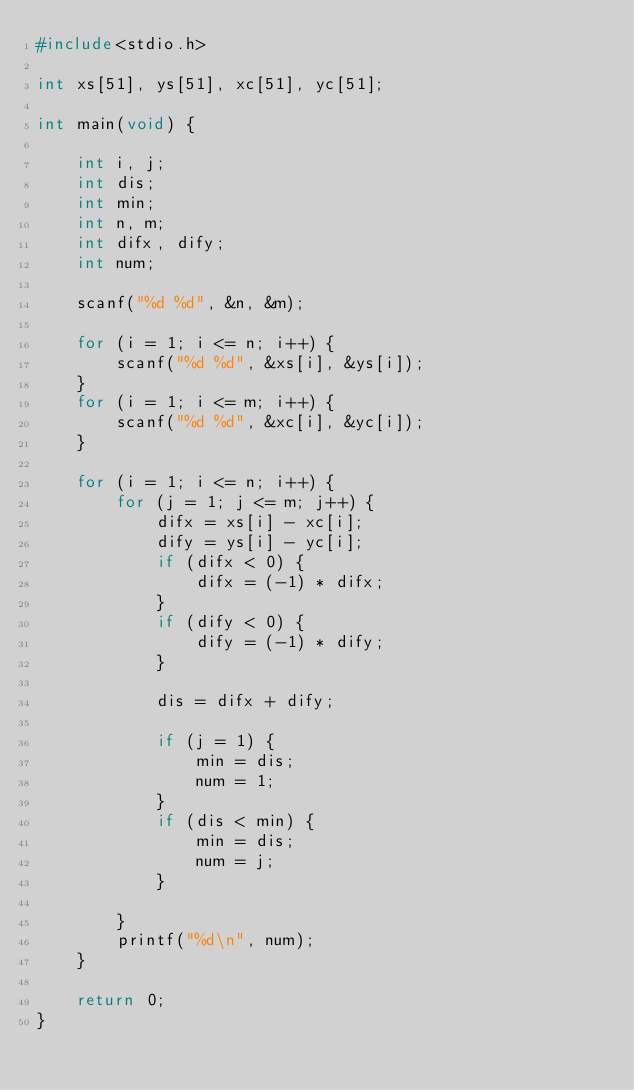Convert code to text. <code><loc_0><loc_0><loc_500><loc_500><_C_>#include<stdio.h>

int xs[51], ys[51], xc[51], yc[51];

int main(void) {

	int i, j;
	int dis;
	int min;
	int n, m;
	int difx, dify;
	int num;

	scanf("%d %d", &n, &m);

	for (i = 1; i <= n; i++) {
		scanf("%d %d", &xs[i], &ys[i]);
	}
	for (i = 1; i <= m; i++) {
		scanf("%d %d", &xc[i], &yc[i]);
	}

	for (i = 1; i <= n; i++) {
		for (j = 1; j <= m; j++) {
			difx = xs[i] - xc[i];
			dify = ys[i] - yc[i];
			if (difx < 0) {
				difx = (-1) * difx;
			}
			if (dify < 0) {
				dify = (-1) * dify;
			}

			dis = difx + dify;

			if (j = 1) {
				min = dis;
				num = 1;
			}
			if (dis < min) {
				min = dis;
				num = j;
			}

		}
		printf("%d\n", num);
	}

	return 0;
}
</code> 